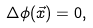<formula> <loc_0><loc_0><loc_500><loc_500>\Delta \phi ( \vec { x } ) = 0 ,</formula> 